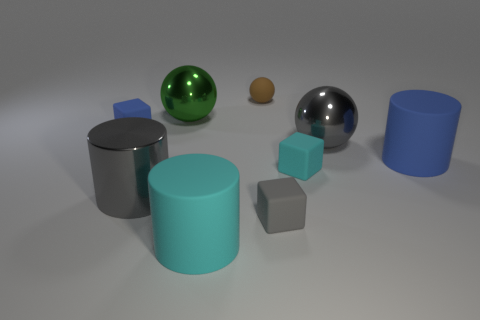Are there the same number of gray shiny cylinders that are left of the tiny blue matte object and large blue cylinders that are behind the brown matte object?
Your response must be concise. Yes. How many tiny gray objects have the same material as the large cyan cylinder?
Ensure brevity in your answer.  1. What is the shape of the small object that is the same color as the big metal cylinder?
Make the answer very short. Cube. How big is the rubber cylinder right of the big metallic sphere that is right of the tiny cyan rubber block?
Make the answer very short. Large. There is a gray metallic object that is right of the big cyan matte cylinder; is it the same shape as the cyan matte thing to the right of the small brown object?
Your response must be concise. No. Are there the same number of small cyan blocks on the left side of the tiny brown matte sphere and big blue cylinders?
Keep it short and to the point. No. The other large thing that is the same shape as the green shiny thing is what color?
Offer a terse response. Gray. Is the material of the tiny block that is on the left side of the small brown matte sphere the same as the green ball?
Your answer should be compact. No. What number of small objects are cyan matte things or gray cubes?
Make the answer very short. 2. The gray cylinder is what size?
Offer a terse response. Large. 